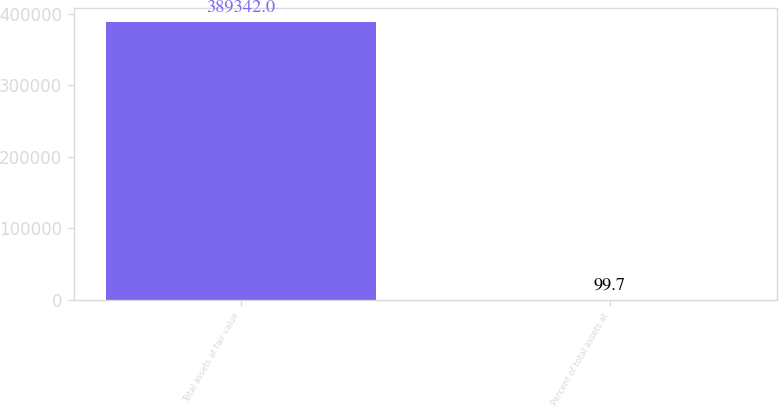<chart> <loc_0><loc_0><loc_500><loc_500><bar_chart><fcel>Total assets at fair value<fcel>Percent of total assets at<nl><fcel>389342<fcel>99.7<nl></chart> 